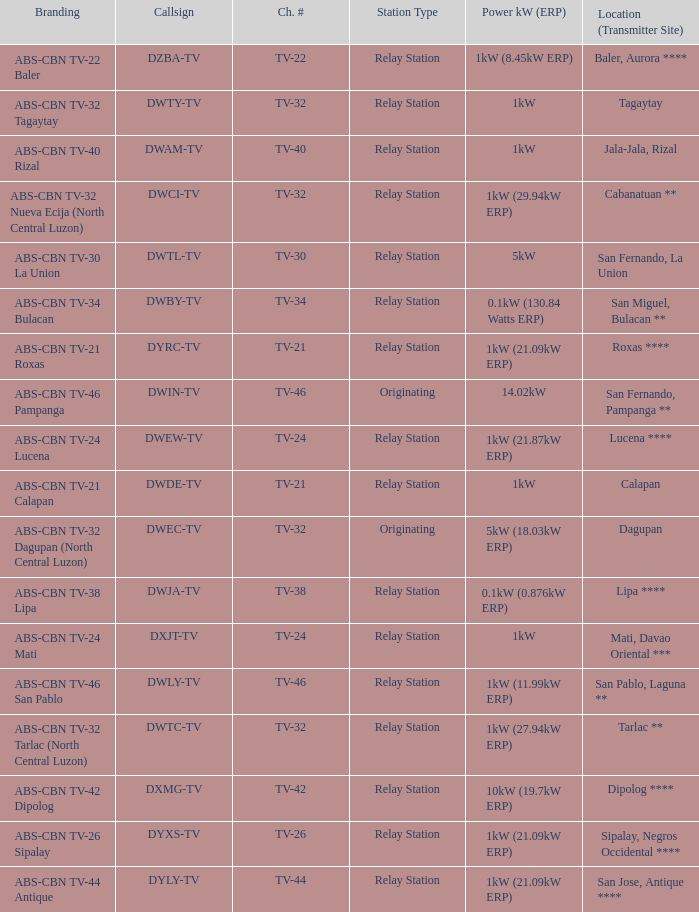What is the branding of the callsign DWCI-TV? ABS-CBN TV-32 Nueva Ecija (North Central Luzon). 